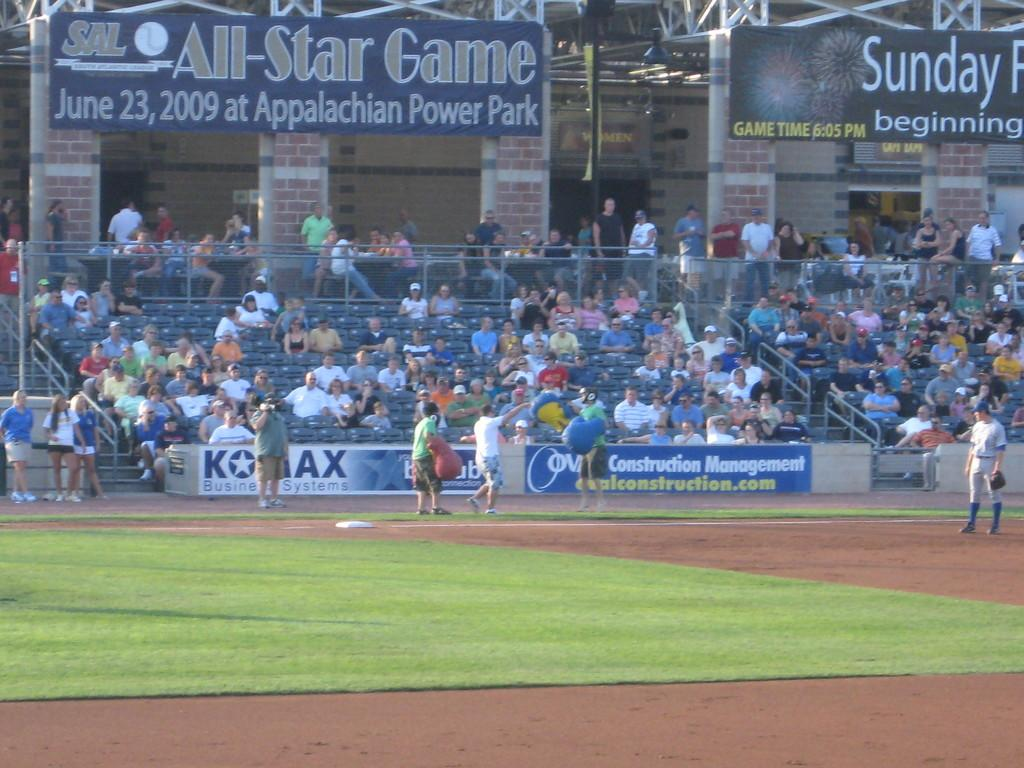Provide a one-sentence caption for the provided image. the all star game taking place at the appalachian power park. 